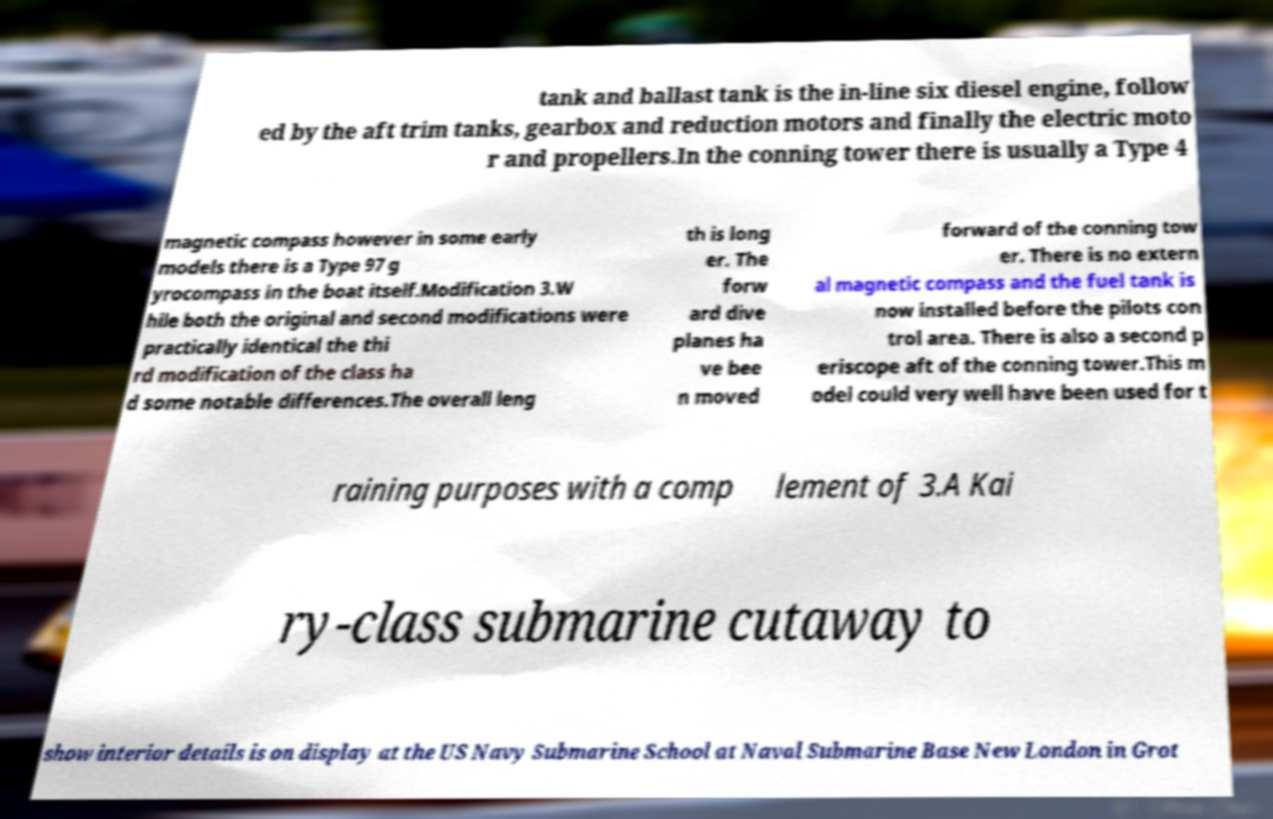I need the written content from this picture converted into text. Can you do that? tank and ballast tank is the in-line six diesel engine, follow ed by the aft trim tanks, gearbox and reduction motors and finally the electric moto r and propellers.In the conning tower there is usually a Type 4 magnetic compass however in some early models there is a Type 97 g yrocompass in the boat itself.Modification 3.W hile both the original and second modifications were practically identical the thi rd modification of the class ha d some notable differences.The overall leng th is long er. The forw ard dive planes ha ve bee n moved forward of the conning tow er. There is no extern al magnetic compass and the fuel tank is now installed before the pilots con trol area. There is also a second p eriscope aft of the conning tower.This m odel could very well have been used for t raining purposes with a comp lement of 3.A Kai ry-class submarine cutaway to show interior details is on display at the US Navy Submarine School at Naval Submarine Base New London in Grot 